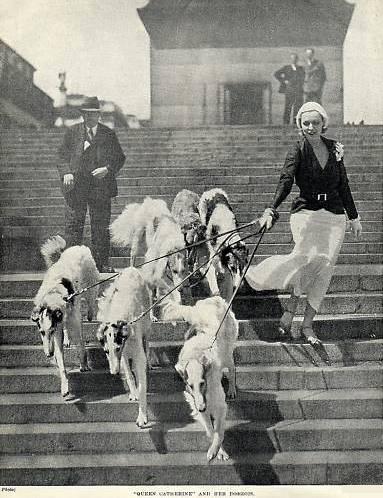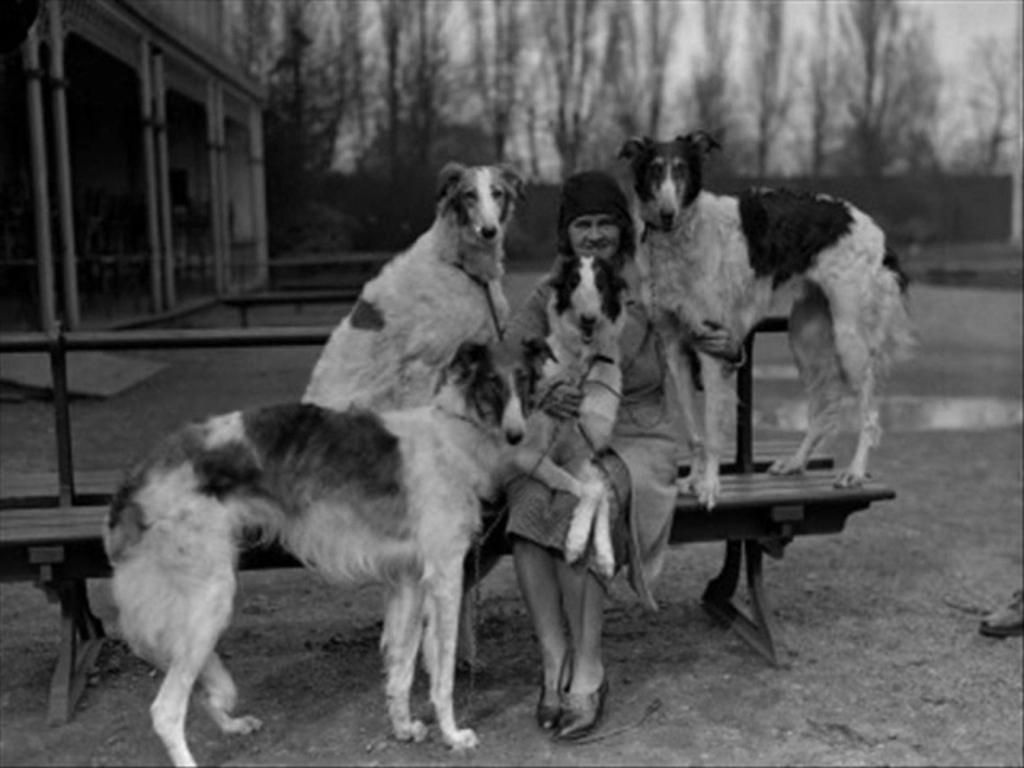The first image is the image on the left, the second image is the image on the right. For the images displayed, is the sentence "A woman is standing with a single dog." factually correct? Answer yes or no. No. The first image is the image on the left, the second image is the image on the right. Evaluate the accuracy of this statement regarding the images: "An image shows a lady in a dark gown standing behind one hound.". Is it true? Answer yes or no. No. 